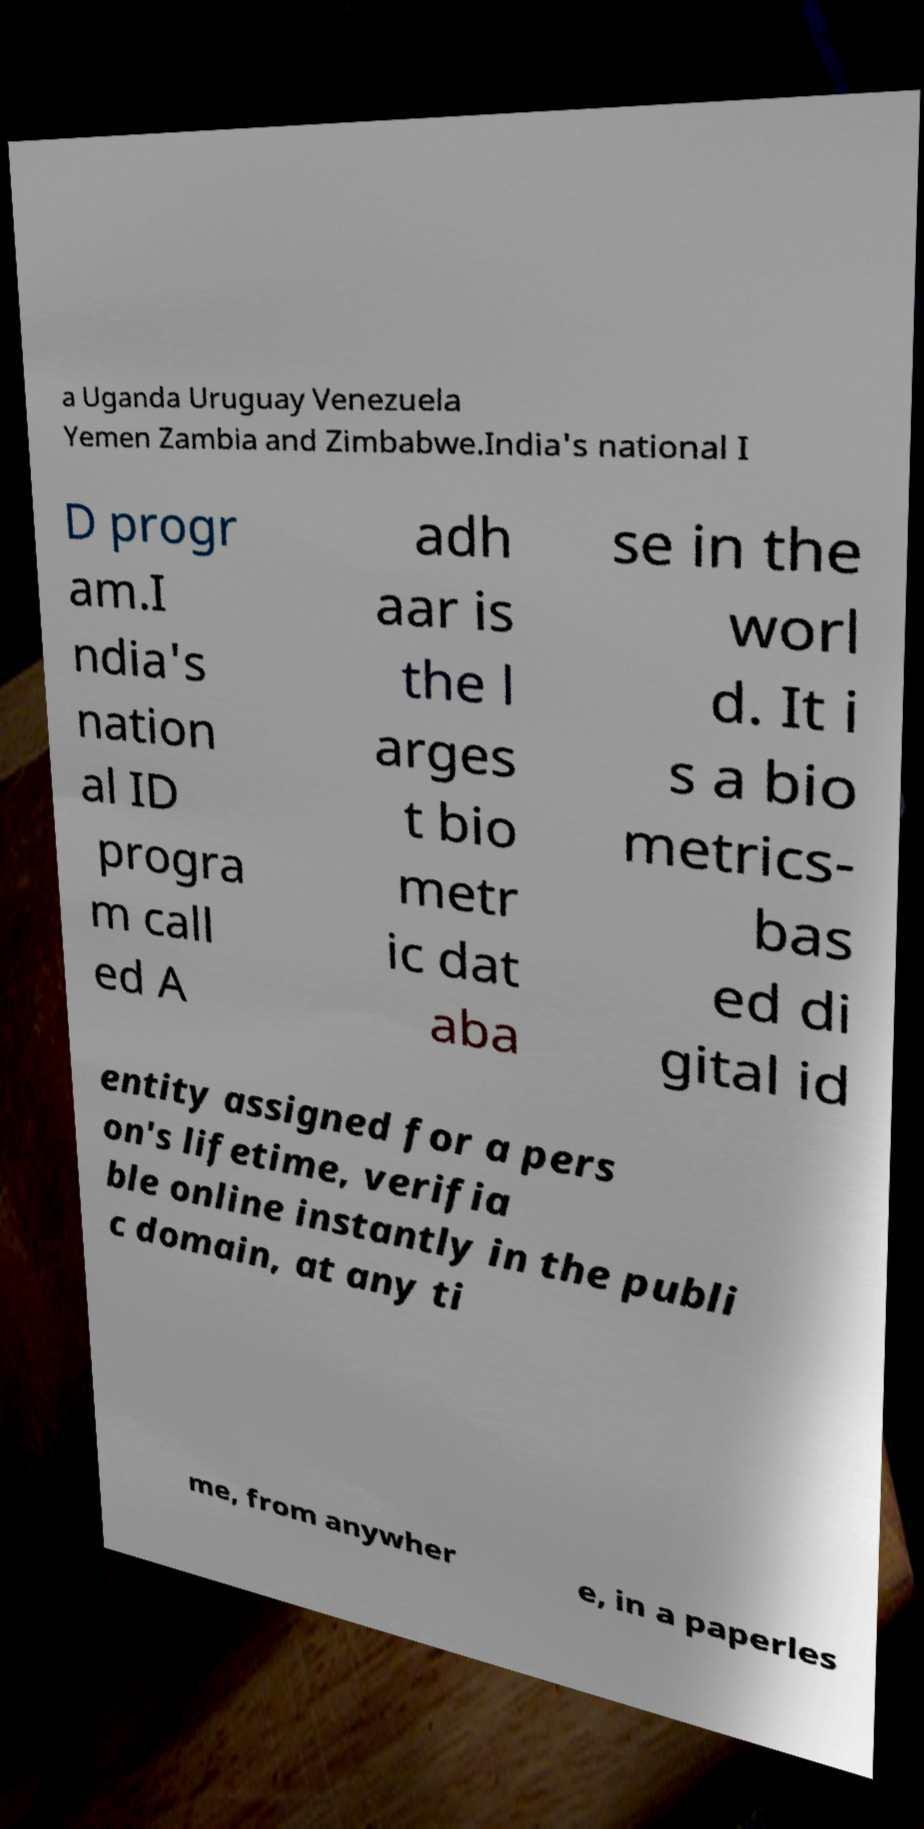Please read and relay the text visible in this image. What does it say? a Uganda Uruguay Venezuela Yemen Zambia and Zimbabwe.India's national I D progr am.I ndia's nation al ID progra m call ed A adh aar is the l arges t bio metr ic dat aba se in the worl d. It i s a bio metrics- bas ed di gital id entity assigned for a pers on's lifetime, verifia ble online instantly in the publi c domain, at any ti me, from anywher e, in a paperles 